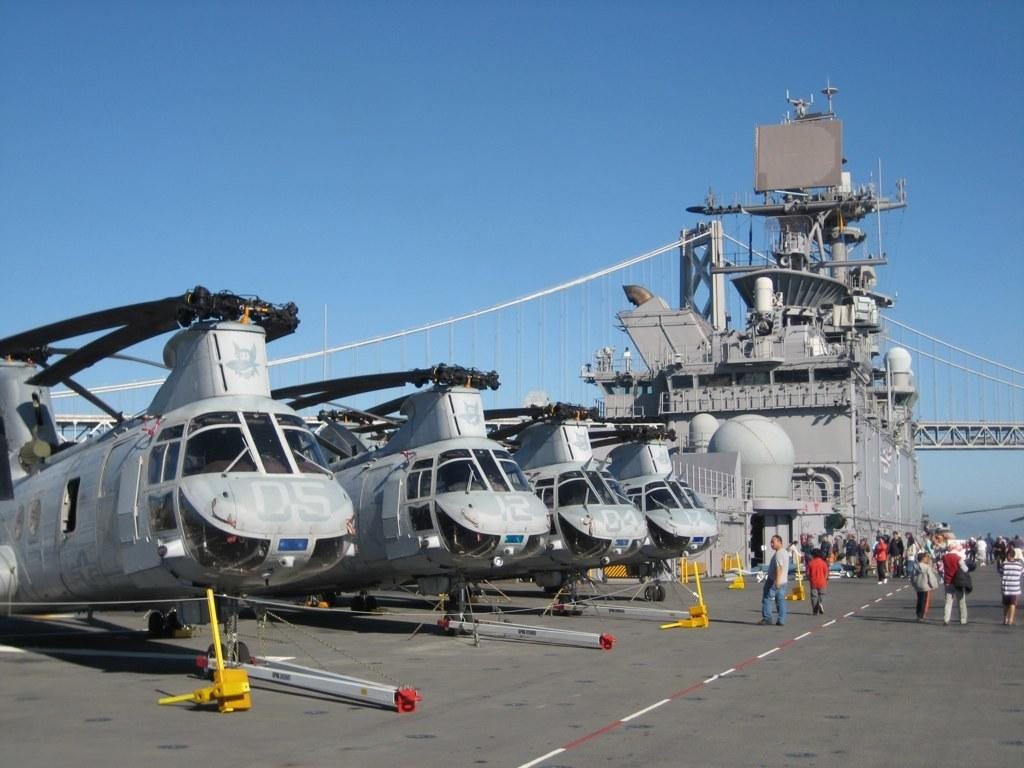What is the main subject of the image? The main subject of the image is planes. What are the people in the image doing? There are people standing on the road in the image. What other objects or structures can be seen in the image? There is a machine and a bridge visible in the image. How would you describe the sky in the image? The sky in the image appears cloudy. What type of stew is being served at the picnic table in the image? There is no picnic table or stew present in the image. How does the pollution affect the people standing on the road in the image? There is no mention of pollution in the image, so we cannot determine its effect on the people. 